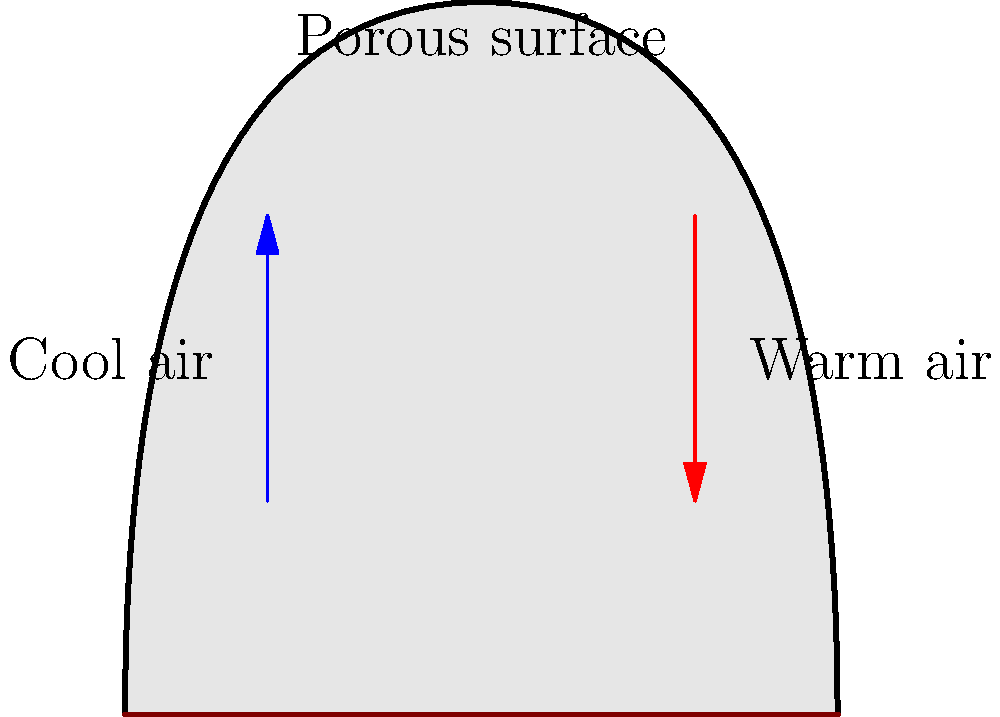In a natural ventilation system inspired by termite mounds, which principle is primarily responsible for creating air circulation without mechanical assistance? To understand the natural ventilation system inspired by termite mounds, let's break down the process:

1. Termite mounds have a porous outer surface that allows air to pass through.

2. The internal structure of the mound consists of a complex network of tunnels and chambers.

3. As the sun heats the mound during the day, the air inside warms up.

4. Warm air, being less dense, rises through the central chimney of the mound.

5. This creates a low-pressure area at the bottom of the mound.

6. Cooler air from outside is then drawn in through the porous lower sections of the mound to replace the rising warm air.

7. This process creates a continuous circulation of air, known as the "stack effect" or "chimney effect."

8. The stack effect is driven by the temperature difference between the inside and outside of the mound, as well as the height of the structure.

9. This natural convection process can be described by the equation:

   $$Q = C_d A \sqrt{2gh\frac{\Delta T}{T}}$$

   Where:
   $Q$ = volumetric flow rate
   $C_d$ = discharge coefficient
   $A$ = cross-sectional area of openings
   $g$ = gravitational acceleration
   $h$ = height difference between inlet and outlet
   $\Delta T$ = temperature difference between inside and outside
   $T$ = average temperature

The key principle at work here is thermal buoyancy, which creates natural convection currents without any mechanical assistance.
Answer: Thermal buoyancy (stack effect) 